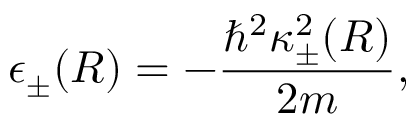Convert formula to latex. <formula><loc_0><loc_0><loc_500><loc_500>\epsilon _ { \pm } ( R ) = - \frac { \hbar { ^ } { 2 } \kappa _ { \pm } ^ { 2 } ( R ) } { 2 m } ,</formula> 